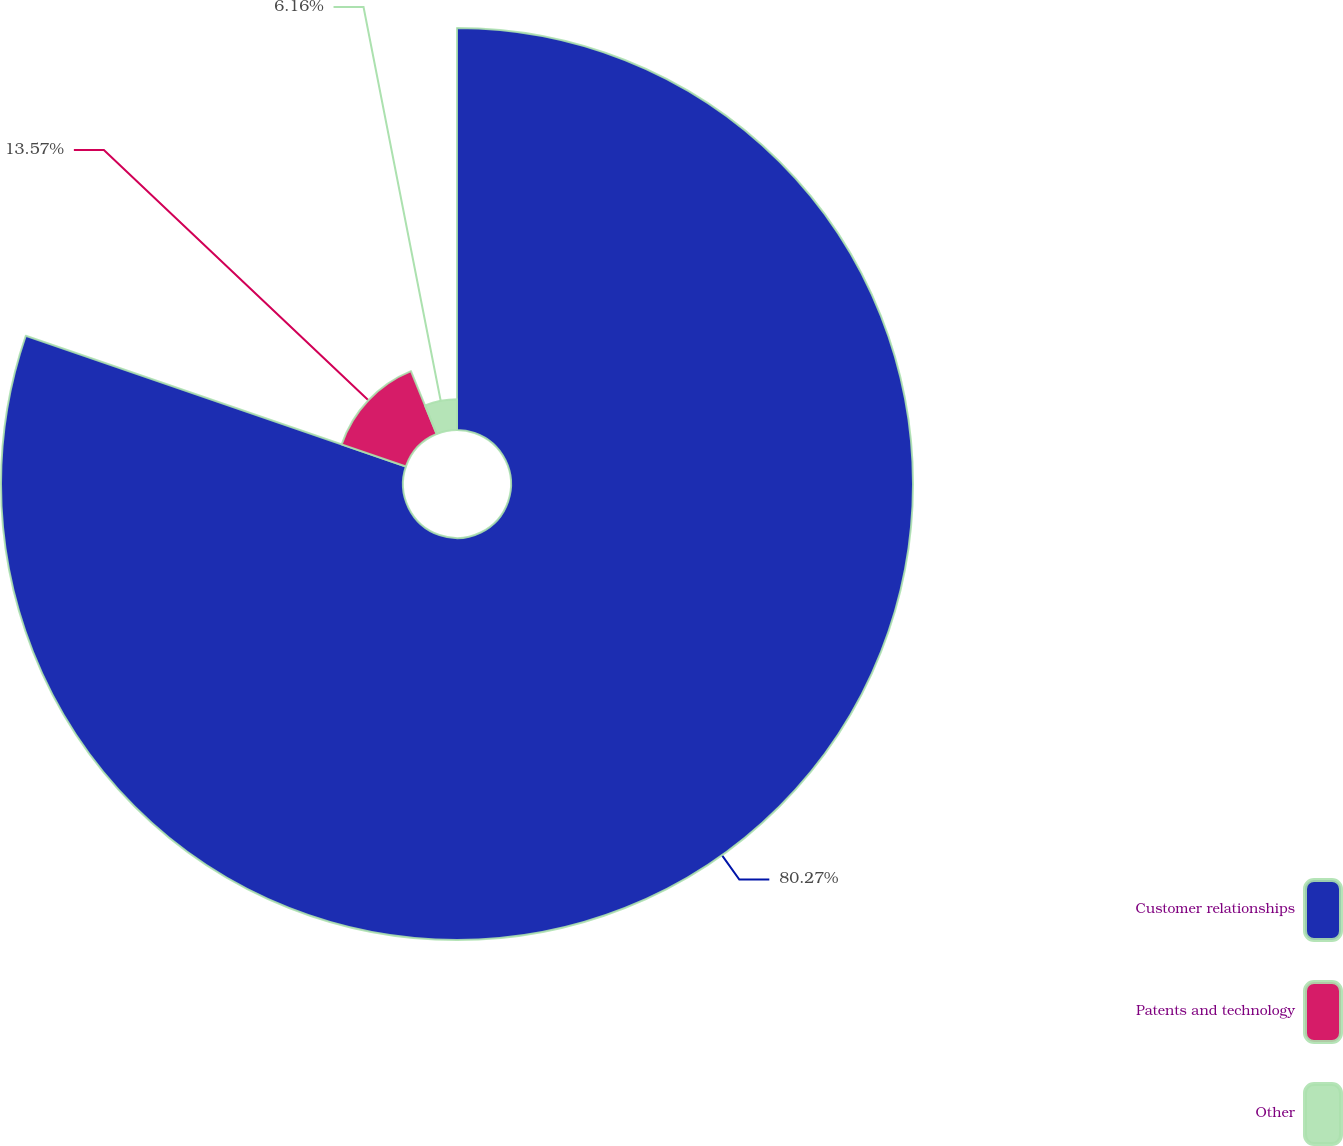<chart> <loc_0><loc_0><loc_500><loc_500><pie_chart><fcel>Customer relationships<fcel>Patents and technology<fcel>Other<nl><fcel>80.27%<fcel>13.57%<fcel>6.16%<nl></chart> 